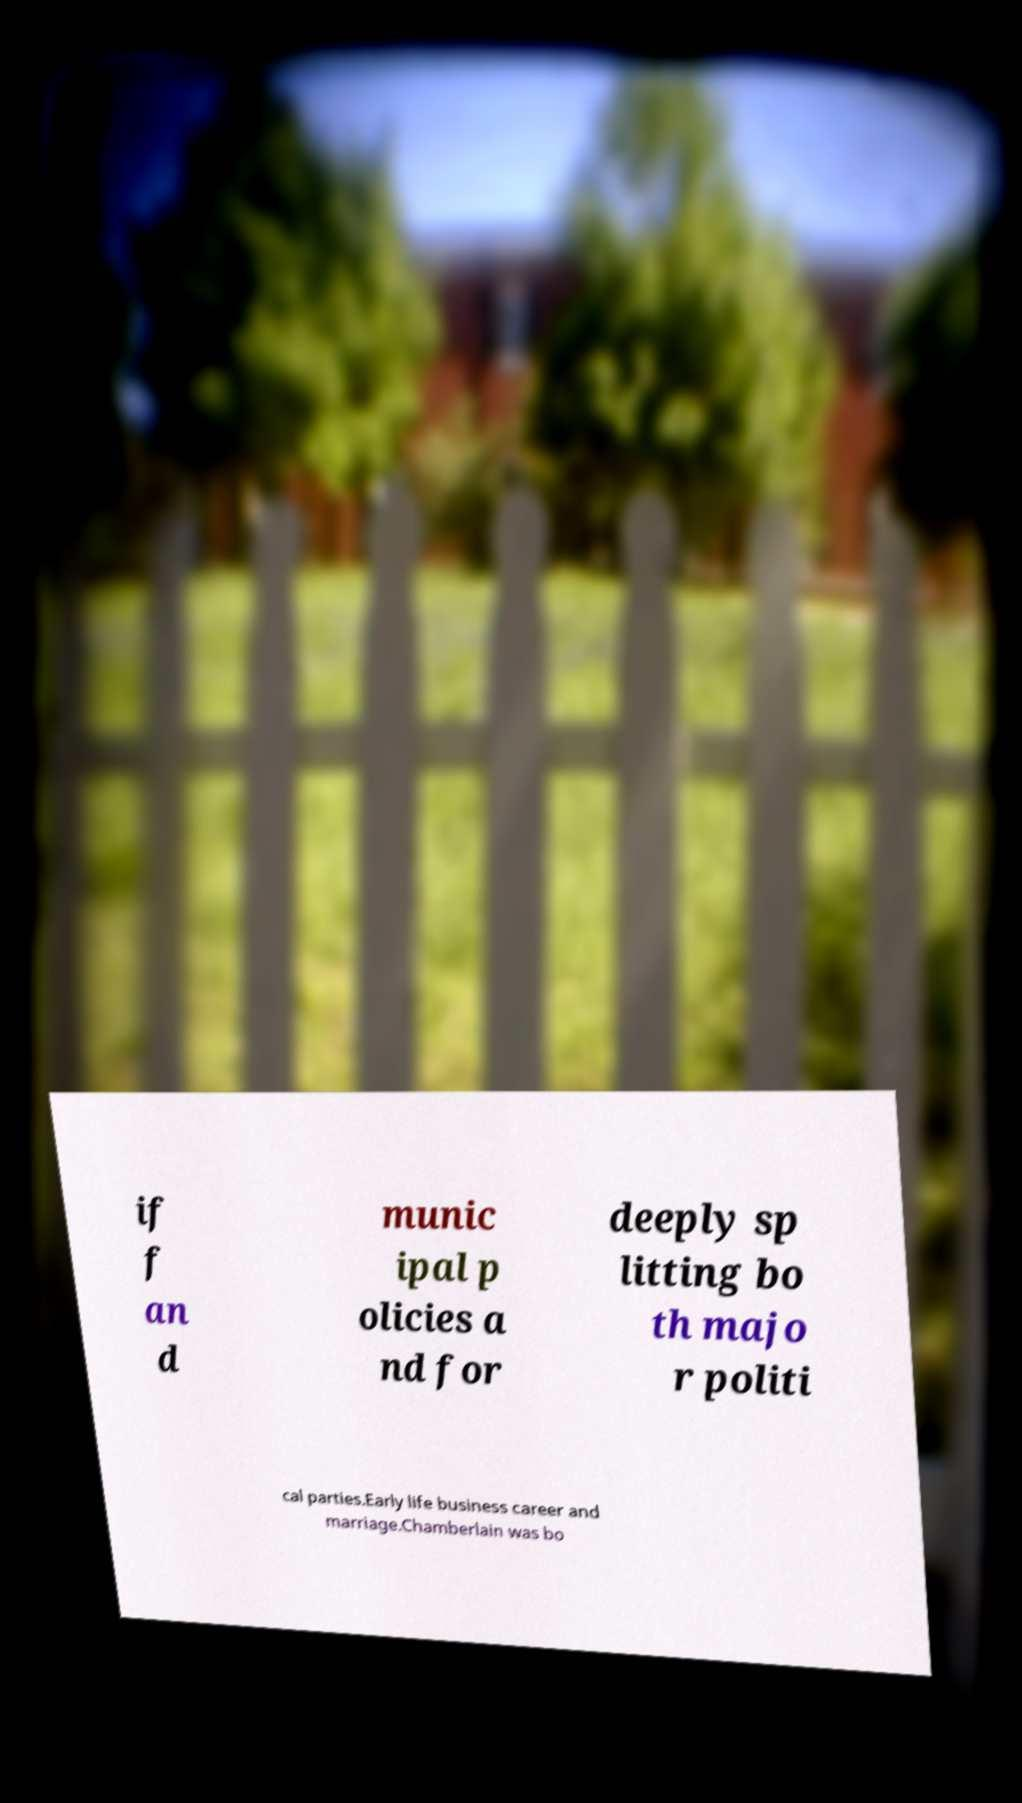Can you accurately transcribe the text from the provided image for me? if f an d munic ipal p olicies a nd for deeply sp litting bo th majo r politi cal parties.Early life business career and marriage.Chamberlain was bo 